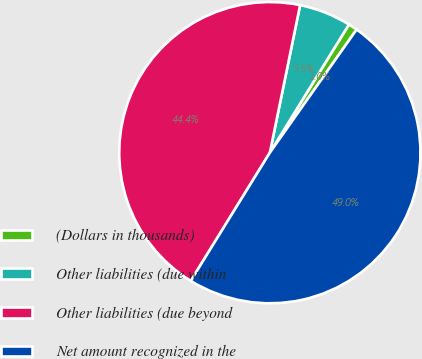Convert chart to OTSL. <chart><loc_0><loc_0><loc_500><loc_500><pie_chart><fcel>(Dollars in thousands)<fcel>Other liabilities (due within<fcel>Other liabilities (due beyond<fcel>Net amount recognized in the<nl><fcel>0.97%<fcel>5.58%<fcel>44.42%<fcel>49.03%<nl></chart> 